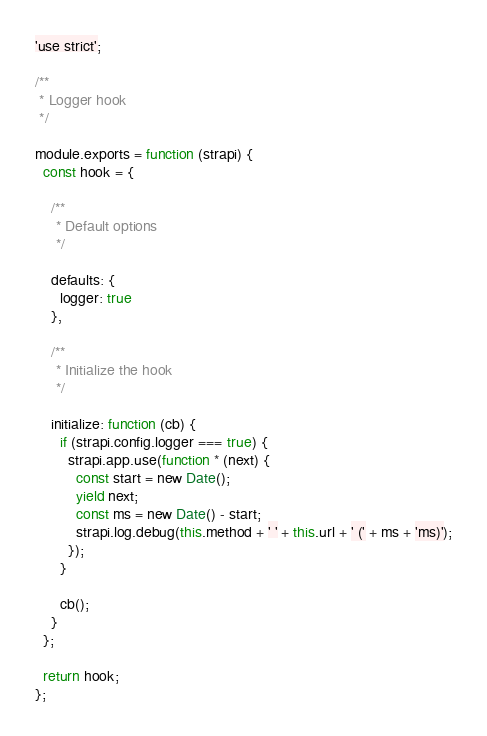<code> <loc_0><loc_0><loc_500><loc_500><_JavaScript_>'use strict';

/**
 * Logger hook
 */

module.exports = function (strapi) {
  const hook = {

    /**
     * Default options
     */

    defaults: {
      logger: true
    },

    /**
     * Initialize the hook
     */

    initialize: function (cb) {
      if (strapi.config.logger === true) {
        strapi.app.use(function * (next) {
          const start = new Date();
          yield next;
          const ms = new Date() - start;
          strapi.log.debug(this.method + ' ' + this.url + ' (' + ms + 'ms)');
        });
      }

      cb();
    }
  };

  return hook;
};
</code> 